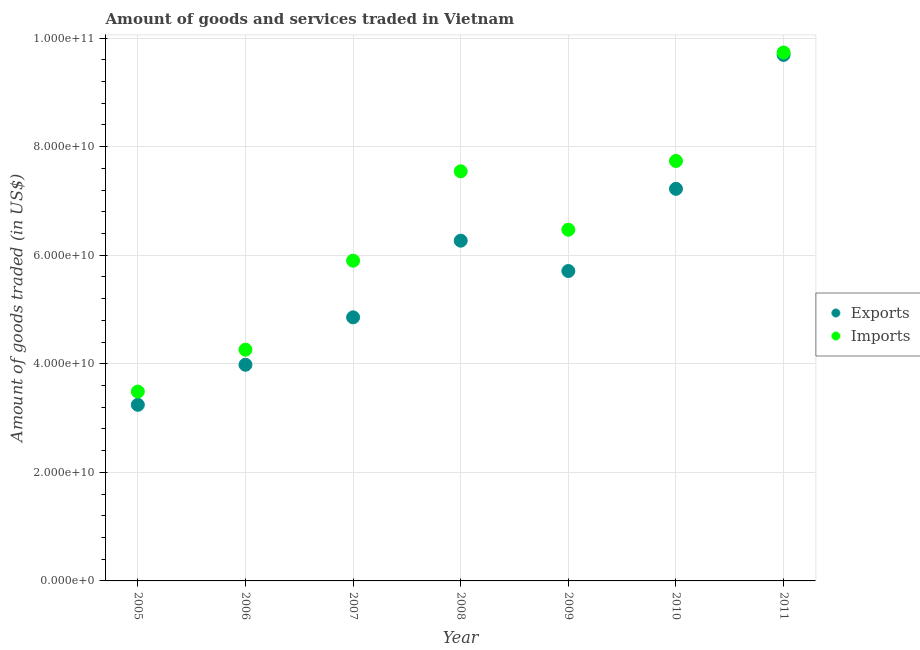How many different coloured dotlines are there?
Keep it short and to the point. 2. Is the number of dotlines equal to the number of legend labels?
Give a very brief answer. Yes. What is the amount of goods imported in 2006?
Offer a terse response. 4.26e+1. Across all years, what is the maximum amount of goods imported?
Your answer should be very brief. 9.74e+1. Across all years, what is the minimum amount of goods imported?
Keep it short and to the point. 3.49e+1. In which year was the amount of goods imported minimum?
Make the answer very short. 2005. What is the total amount of goods imported in the graph?
Provide a succinct answer. 4.51e+11. What is the difference between the amount of goods exported in 2005 and that in 2011?
Your answer should be very brief. -6.45e+1. What is the difference between the amount of goods imported in 2010 and the amount of goods exported in 2005?
Offer a terse response. 4.49e+1. What is the average amount of goods exported per year?
Offer a terse response. 5.85e+1. In the year 2006, what is the difference between the amount of goods imported and amount of goods exported?
Provide a short and direct response. 2.78e+09. What is the ratio of the amount of goods imported in 2005 to that in 2006?
Provide a succinct answer. 0.82. Is the amount of goods exported in 2005 less than that in 2007?
Offer a very short reply. Yes. What is the difference between the highest and the second highest amount of goods exported?
Your answer should be very brief. 2.47e+1. What is the difference between the highest and the lowest amount of goods imported?
Make the answer very short. 6.25e+1. Is the sum of the amount of goods imported in 2005 and 2008 greater than the maximum amount of goods exported across all years?
Give a very brief answer. Yes. Is the amount of goods exported strictly greater than the amount of goods imported over the years?
Provide a succinct answer. No. Is the amount of goods imported strictly less than the amount of goods exported over the years?
Your response must be concise. No. What is the difference between two consecutive major ticks on the Y-axis?
Ensure brevity in your answer.  2.00e+1. Where does the legend appear in the graph?
Offer a very short reply. Center right. What is the title of the graph?
Keep it short and to the point. Amount of goods and services traded in Vietnam. What is the label or title of the X-axis?
Give a very brief answer. Year. What is the label or title of the Y-axis?
Keep it short and to the point. Amount of goods traded (in US$). What is the Amount of goods traded (in US$) of Exports in 2005?
Give a very brief answer. 3.24e+1. What is the Amount of goods traded (in US$) in Imports in 2005?
Offer a terse response. 3.49e+1. What is the Amount of goods traded (in US$) of Exports in 2006?
Make the answer very short. 3.98e+1. What is the Amount of goods traded (in US$) of Imports in 2006?
Your answer should be compact. 4.26e+1. What is the Amount of goods traded (in US$) in Exports in 2007?
Offer a very short reply. 4.86e+1. What is the Amount of goods traded (in US$) in Imports in 2007?
Make the answer very short. 5.90e+1. What is the Amount of goods traded (in US$) of Exports in 2008?
Provide a succinct answer. 6.27e+1. What is the Amount of goods traded (in US$) in Imports in 2008?
Your answer should be very brief. 7.55e+1. What is the Amount of goods traded (in US$) in Exports in 2009?
Offer a terse response. 5.71e+1. What is the Amount of goods traded (in US$) in Imports in 2009?
Your answer should be very brief. 6.47e+1. What is the Amount of goods traded (in US$) in Exports in 2010?
Keep it short and to the point. 7.22e+1. What is the Amount of goods traded (in US$) of Imports in 2010?
Give a very brief answer. 7.74e+1. What is the Amount of goods traded (in US$) of Exports in 2011?
Your response must be concise. 9.69e+1. What is the Amount of goods traded (in US$) of Imports in 2011?
Keep it short and to the point. 9.74e+1. Across all years, what is the maximum Amount of goods traded (in US$) of Exports?
Your response must be concise. 9.69e+1. Across all years, what is the maximum Amount of goods traded (in US$) of Imports?
Your response must be concise. 9.74e+1. Across all years, what is the minimum Amount of goods traded (in US$) of Exports?
Provide a succinct answer. 3.24e+1. Across all years, what is the minimum Amount of goods traded (in US$) in Imports?
Provide a short and direct response. 3.49e+1. What is the total Amount of goods traded (in US$) in Exports in the graph?
Keep it short and to the point. 4.10e+11. What is the total Amount of goods traded (in US$) in Imports in the graph?
Provide a short and direct response. 4.51e+11. What is the difference between the Amount of goods traded (in US$) in Exports in 2005 and that in 2006?
Keep it short and to the point. -7.38e+09. What is the difference between the Amount of goods traded (in US$) of Imports in 2005 and that in 2006?
Offer a terse response. -7.72e+09. What is the difference between the Amount of goods traded (in US$) of Exports in 2005 and that in 2007?
Ensure brevity in your answer.  -1.61e+1. What is the difference between the Amount of goods traded (in US$) of Imports in 2005 and that in 2007?
Your response must be concise. -2.41e+1. What is the difference between the Amount of goods traded (in US$) in Exports in 2005 and that in 2008?
Your answer should be compact. -3.02e+1. What is the difference between the Amount of goods traded (in US$) in Imports in 2005 and that in 2008?
Offer a terse response. -4.06e+1. What is the difference between the Amount of goods traded (in US$) of Exports in 2005 and that in 2009?
Make the answer very short. -2.46e+1. What is the difference between the Amount of goods traded (in US$) of Imports in 2005 and that in 2009?
Your answer should be very brief. -2.98e+1. What is the difference between the Amount of goods traded (in US$) in Exports in 2005 and that in 2010?
Ensure brevity in your answer.  -3.98e+1. What is the difference between the Amount of goods traded (in US$) of Imports in 2005 and that in 2010?
Your answer should be very brief. -4.25e+1. What is the difference between the Amount of goods traded (in US$) of Exports in 2005 and that in 2011?
Your answer should be very brief. -6.45e+1. What is the difference between the Amount of goods traded (in US$) of Imports in 2005 and that in 2011?
Ensure brevity in your answer.  -6.25e+1. What is the difference between the Amount of goods traded (in US$) in Exports in 2006 and that in 2007?
Offer a very short reply. -8.74e+09. What is the difference between the Amount of goods traded (in US$) of Imports in 2006 and that in 2007?
Provide a succinct answer. -1.64e+1. What is the difference between the Amount of goods traded (in US$) of Exports in 2006 and that in 2008?
Your answer should be compact. -2.29e+1. What is the difference between the Amount of goods traded (in US$) in Imports in 2006 and that in 2008?
Your response must be concise. -3.29e+1. What is the difference between the Amount of goods traded (in US$) of Exports in 2006 and that in 2009?
Offer a terse response. -1.73e+1. What is the difference between the Amount of goods traded (in US$) of Imports in 2006 and that in 2009?
Your answer should be very brief. -2.21e+1. What is the difference between the Amount of goods traded (in US$) in Exports in 2006 and that in 2010?
Ensure brevity in your answer.  -3.24e+1. What is the difference between the Amount of goods traded (in US$) in Imports in 2006 and that in 2010?
Offer a terse response. -3.48e+1. What is the difference between the Amount of goods traded (in US$) of Exports in 2006 and that in 2011?
Make the answer very short. -5.71e+1. What is the difference between the Amount of goods traded (in US$) in Imports in 2006 and that in 2011?
Keep it short and to the point. -5.48e+1. What is the difference between the Amount of goods traded (in US$) in Exports in 2007 and that in 2008?
Give a very brief answer. -1.41e+1. What is the difference between the Amount of goods traded (in US$) in Imports in 2007 and that in 2008?
Ensure brevity in your answer.  -1.65e+1. What is the difference between the Amount of goods traded (in US$) in Exports in 2007 and that in 2009?
Your answer should be very brief. -8.54e+09. What is the difference between the Amount of goods traded (in US$) of Imports in 2007 and that in 2009?
Give a very brief answer. -5.70e+09. What is the difference between the Amount of goods traded (in US$) of Exports in 2007 and that in 2010?
Ensure brevity in your answer.  -2.37e+1. What is the difference between the Amount of goods traded (in US$) of Imports in 2007 and that in 2010?
Your answer should be compact. -1.84e+1. What is the difference between the Amount of goods traded (in US$) of Exports in 2007 and that in 2011?
Your answer should be compact. -4.83e+1. What is the difference between the Amount of goods traded (in US$) in Imports in 2007 and that in 2011?
Keep it short and to the point. -3.84e+1. What is the difference between the Amount of goods traded (in US$) of Exports in 2008 and that in 2009?
Provide a short and direct response. 5.59e+09. What is the difference between the Amount of goods traded (in US$) of Imports in 2008 and that in 2009?
Provide a succinct answer. 1.08e+1. What is the difference between the Amount of goods traded (in US$) in Exports in 2008 and that in 2010?
Your response must be concise. -9.55e+09. What is the difference between the Amount of goods traded (in US$) in Imports in 2008 and that in 2010?
Your answer should be very brief. -1.90e+09. What is the difference between the Amount of goods traded (in US$) in Exports in 2008 and that in 2011?
Offer a very short reply. -3.42e+1. What is the difference between the Amount of goods traded (in US$) of Imports in 2008 and that in 2011?
Offer a terse response. -2.19e+1. What is the difference between the Amount of goods traded (in US$) in Exports in 2009 and that in 2010?
Your answer should be compact. -1.51e+1. What is the difference between the Amount of goods traded (in US$) in Imports in 2009 and that in 2010?
Your answer should be compact. -1.27e+1. What is the difference between the Amount of goods traded (in US$) of Exports in 2009 and that in 2011?
Your response must be concise. -3.98e+1. What is the difference between the Amount of goods traded (in US$) of Imports in 2009 and that in 2011?
Offer a terse response. -3.27e+1. What is the difference between the Amount of goods traded (in US$) in Exports in 2010 and that in 2011?
Provide a short and direct response. -2.47e+1. What is the difference between the Amount of goods traded (in US$) of Imports in 2010 and that in 2011?
Provide a short and direct response. -2.00e+1. What is the difference between the Amount of goods traded (in US$) in Exports in 2005 and the Amount of goods traded (in US$) in Imports in 2006?
Provide a succinct answer. -1.02e+1. What is the difference between the Amount of goods traded (in US$) in Exports in 2005 and the Amount of goods traded (in US$) in Imports in 2007?
Ensure brevity in your answer.  -2.66e+1. What is the difference between the Amount of goods traded (in US$) of Exports in 2005 and the Amount of goods traded (in US$) of Imports in 2008?
Make the answer very short. -4.30e+1. What is the difference between the Amount of goods traded (in US$) in Exports in 2005 and the Amount of goods traded (in US$) in Imports in 2009?
Your answer should be very brief. -3.23e+1. What is the difference between the Amount of goods traded (in US$) of Exports in 2005 and the Amount of goods traded (in US$) of Imports in 2010?
Offer a terse response. -4.49e+1. What is the difference between the Amount of goods traded (in US$) in Exports in 2005 and the Amount of goods traded (in US$) in Imports in 2011?
Make the answer very short. -6.49e+1. What is the difference between the Amount of goods traded (in US$) of Exports in 2006 and the Amount of goods traded (in US$) of Imports in 2007?
Your response must be concise. -1.92e+1. What is the difference between the Amount of goods traded (in US$) in Exports in 2006 and the Amount of goods traded (in US$) in Imports in 2008?
Offer a very short reply. -3.56e+1. What is the difference between the Amount of goods traded (in US$) in Exports in 2006 and the Amount of goods traded (in US$) in Imports in 2009?
Keep it short and to the point. -2.49e+1. What is the difference between the Amount of goods traded (in US$) of Exports in 2006 and the Amount of goods traded (in US$) of Imports in 2010?
Provide a succinct answer. -3.75e+1. What is the difference between the Amount of goods traded (in US$) of Exports in 2006 and the Amount of goods traded (in US$) of Imports in 2011?
Your answer should be very brief. -5.75e+1. What is the difference between the Amount of goods traded (in US$) of Exports in 2007 and the Amount of goods traded (in US$) of Imports in 2008?
Your answer should be very brief. -2.69e+1. What is the difference between the Amount of goods traded (in US$) in Exports in 2007 and the Amount of goods traded (in US$) in Imports in 2009?
Ensure brevity in your answer.  -1.61e+1. What is the difference between the Amount of goods traded (in US$) in Exports in 2007 and the Amount of goods traded (in US$) in Imports in 2010?
Your answer should be very brief. -2.88e+1. What is the difference between the Amount of goods traded (in US$) in Exports in 2007 and the Amount of goods traded (in US$) in Imports in 2011?
Provide a short and direct response. -4.88e+1. What is the difference between the Amount of goods traded (in US$) of Exports in 2008 and the Amount of goods traded (in US$) of Imports in 2009?
Offer a very short reply. -2.02e+09. What is the difference between the Amount of goods traded (in US$) in Exports in 2008 and the Amount of goods traded (in US$) in Imports in 2010?
Your answer should be compact. -1.47e+1. What is the difference between the Amount of goods traded (in US$) in Exports in 2008 and the Amount of goods traded (in US$) in Imports in 2011?
Provide a short and direct response. -3.47e+1. What is the difference between the Amount of goods traded (in US$) of Exports in 2009 and the Amount of goods traded (in US$) of Imports in 2010?
Offer a terse response. -2.03e+1. What is the difference between the Amount of goods traded (in US$) in Exports in 2009 and the Amount of goods traded (in US$) in Imports in 2011?
Ensure brevity in your answer.  -4.03e+1. What is the difference between the Amount of goods traded (in US$) in Exports in 2010 and the Amount of goods traded (in US$) in Imports in 2011?
Offer a terse response. -2.51e+1. What is the average Amount of goods traded (in US$) in Exports per year?
Offer a very short reply. 5.85e+1. What is the average Amount of goods traded (in US$) in Imports per year?
Give a very brief answer. 6.45e+1. In the year 2005, what is the difference between the Amount of goods traded (in US$) of Exports and Amount of goods traded (in US$) of Imports?
Keep it short and to the point. -2.44e+09. In the year 2006, what is the difference between the Amount of goods traded (in US$) of Exports and Amount of goods traded (in US$) of Imports?
Keep it short and to the point. -2.78e+09. In the year 2007, what is the difference between the Amount of goods traded (in US$) in Exports and Amount of goods traded (in US$) in Imports?
Offer a terse response. -1.04e+1. In the year 2008, what is the difference between the Amount of goods traded (in US$) of Exports and Amount of goods traded (in US$) of Imports?
Your answer should be compact. -1.28e+1. In the year 2009, what is the difference between the Amount of goods traded (in US$) of Exports and Amount of goods traded (in US$) of Imports?
Make the answer very short. -7.61e+09. In the year 2010, what is the difference between the Amount of goods traded (in US$) in Exports and Amount of goods traded (in US$) in Imports?
Offer a terse response. -5.14e+09. In the year 2011, what is the difference between the Amount of goods traded (in US$) in Exports and Amount of goods traded (in US$) in Imports?
Ensure brevity in your answer.  -4.50e+08. What is the ratio of the Amount of goods traded (in US$) of Exports in 2005 to that in 2006?
Your response must be concise. 0.81. What is the ratio of the Amount of goods traded (in US$) of Imports in 2005 to that in 2006?
Ensure brevity in your answer.  0.82. What is the ratio of the Amount of goods traded (in US$) in Exports in 2005 to that in 2007?
Provide a succinct answer. 0.67. What is the ratio of the Amount of goods traded (in US$) of Imports in 2005 to that in 2007?
Ensure brevity in your answer.  0.59. What is the ratio of the Amount of goods traded (in US$) in Exports in 2005 to that in 2008?
Offer a very short reply. 0.52. What is the ratio of the Amount of goods traded (in US$) in Imports in 2005 to that in 2008?
Your answer should be very brief. 0.46. What is the ratio of the Amount of goods traded (in US$) in Exports in 2005 to that in 2009?
Provide a short and direct response. 0.57. What is the ratio of the Amount of goods traded (in US$) of Imports in 2005 to that in 2009?
Make the answer very short. 0.54. What is the ratio of the Amount of goods traded (in US$) of Exports in 2005 to that in 2010?
Your answer should be very brief. 0.45. What is the ratio of the Amount of goods traded (in US$) in Imports in 2005 to that in 2010?
Ensure brevity in your answer.  0.45. What is the ratio of the Amount of goods traded (in US$) of Exports in 2005 to that in 2011?
Your response must be concise. 0.33. What is the ratio of the Amount of goods traded (in US$) of Imports in 2005 to that in 2011?
Provide a short and direct response. 0.36. What is the ratio of the Amount of goods traded (in US$) in Exports in 2006 to that in 2007?
Ensure brevity in your answer.  0.82. What is the ratio of the Amount of goods traded (in US$) of Imports in 2006 to that in 2007?
Your response must be concise. 0.72. What is the ratio of the Amount of goods traded (in US$) of Exports in 2006 to that in 2008?
Provide a succinct answer. 0.64. What is the ratio of the Amount of goods traded (in US$) in Imports in 2006 to that in 2008?
Offer a terse response. 0.56. What is the ratio of the Amount of goods traded (in US$) of Exports in 2006 to that in 2009?
Provide a succinct answer. 0.7. What is the ratio of the Amount of goods traded (in US$) of Imports in 2006 to that in 2009?
Offer a very short reply. 0.66. What is the ratio of the Amount of goods traded (in US$) in Exports in 2006 to that in 2010?
Offer a terse response. 0.55. What is the ratio of the Amount of goods traded (in US$) of Imports in 2006 to that in 2010?
Ensure brevity in your answer.  0.55. What is the ratio of the Amount of goods traded (in US$) of Exports in 2006 to that in 2011?
Make the answer very short. 0.41. What is the ratio of the Amount of goods traded (in US$) in Imports in 2006 to that in 2011?
Keep it short and to the point. 0.44. What is the ratio of the Amount of goods traded (in US$) in Exports in 2007 to that in 2008?
Provide a short and direct response. 0.77. What is the ratio of the Amount of goods traded (in US$) in Imports in 2007 to that in 2008?
Ensure brevity in your answer.  0.78. What is the ratio of the Amount of goods traded (in US$) of Exports in 2007 to that in 2009?
Your answer should be compact. 0.85. What is the ratio of the Amount of goods traded (in US$) of Imports in 2007 to that in 2009?
Provide a short and direct response. 0.91. What is the ratio of the Amount of goods traded (in US$) of Exports in 2007 to that in 2010?
Ensure brevity in your answer.  0.67. What is the ratio of the Amount of goods traded (in US$) of Imports in 2007 to that in 2010?
Your answer should be very brief. 0.76. What is the ratio of the Amount of goods traded (in US$) in Exports in 2007 to that in 2011?
Your response must be concise. 0.5. What is the ratio of the Amount of goods traded (in US$) of Imports in 2007 to that in 2011?
Your answer should be compact. 0.61. What is the ratio of the Amount of goods traded (in US$) of Exports in 2008 to that in 2009?
Your response must be concise. 1.1. What is the ratio of the Amount of goods traded (in US$) of Imports in 2008 to that in 2009?
Give a very brief answer. 1.17. What is the ratio of the Amount of goods traded (in US$) of Exports in 2008 to that in 2010?
Ensure brevity in your answer.  0.87. What is the ratio of the Amount of goods traded (in US$) of Imports in 2008 to that in 2010?
Provide a succinct answer. 0.98. What is the ratio of the Amount of goods traded (in US$) in Exports in 2008 to that in 2011?
Ensure brevity in your answer.  0.65. What is the ratio of the Amount of goods traded (in US$) of Imports in 2008 to that in 2011?
Make the answer very short. 0.78. What is the ratio of the Amount of goods traded (in US$) of Exports in 2009 to that in 2010?
Your response must be concise. 0.79. What is the ratio of the Amount of goods traded (in US$) in Imports in 2009 to that in 2010?
Your answer should be compact. 0.84. What is the ratio of the Amount of goods traded (in US$) of Exports in 2009 to that in 2011?
Your answer should be compact. 0.59. What is the ratio of the Amount of goods traded (in US$) in Imports in 2009 to that in 2011?
Give a very brief answer. 0.66. What is the ratio of the Amount of goods traded (in US$) in Exports in 2010 to that in 2011?
Offer a terse response. 0.75. What is the ratio of the Amount of goods traded (in US$) of Imports in 2010 to that in 2011?
Ensure brevity in your answer.  0.79. What is the difference between the highest and the second highest Amount of goods traded (in US$) in Exports?
Ensure brevity in your answer.  2.47e+1. What is the difference between the highest and the second highest Amount of goods traded (in US$) in Imports?
Your answer should be very brief. 2.00e+1. What is the difference between the highest and the lowest Amount of goods traded (in US$) in Exports?
Make the answer very short. 6.45e+1. What is the difference between the highest and the lowest Amount of goods traded (in US$) in Imports?
Your response must be concise. 6.25e+1. 